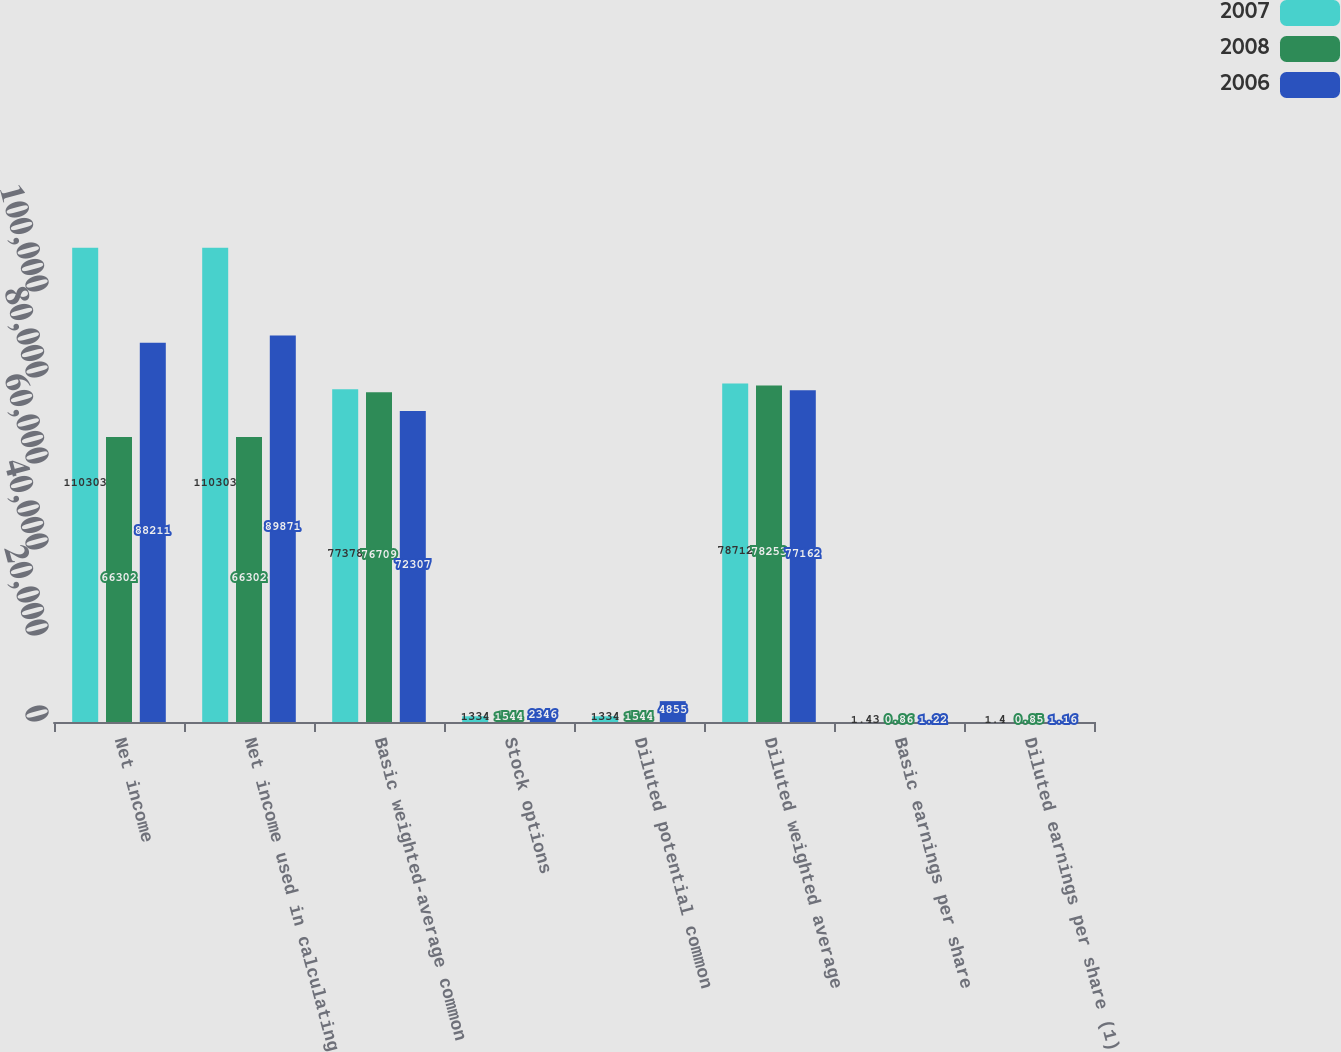Convert chart. <chart><loc_0><loc_0><loc_500><loc_500><stacked_bar_chart><ecel><fcel>Net income<fcel>Net income used in calculating<fcel>Basic weighted-average common<fcel>Stock options<fcel>Diluted potential common<fcel>Diluted weighted average<fcel>Basic earnings per share<fcel>Diluted earnings per share (1)<nl><fcel>2007<fcel>110303<fcel>110303<fcel>77378<fcel>1334<fcel>1334<fcel>78712<fcel>1.43<fcel>1.4<nl><fcel>2008<fcel>66302<fcel>66302<fcel>76709<fcel>1544<fcel>1544<fcel>78253<fcel>0.86<fcel>0.85<nl><fcel>2006<fcel>88211<fcel>89871<fcel>72307<fcel>2346<fcel>4855<fcel>77162<fcel>1.22<fcel>1.16<nl></chart> 